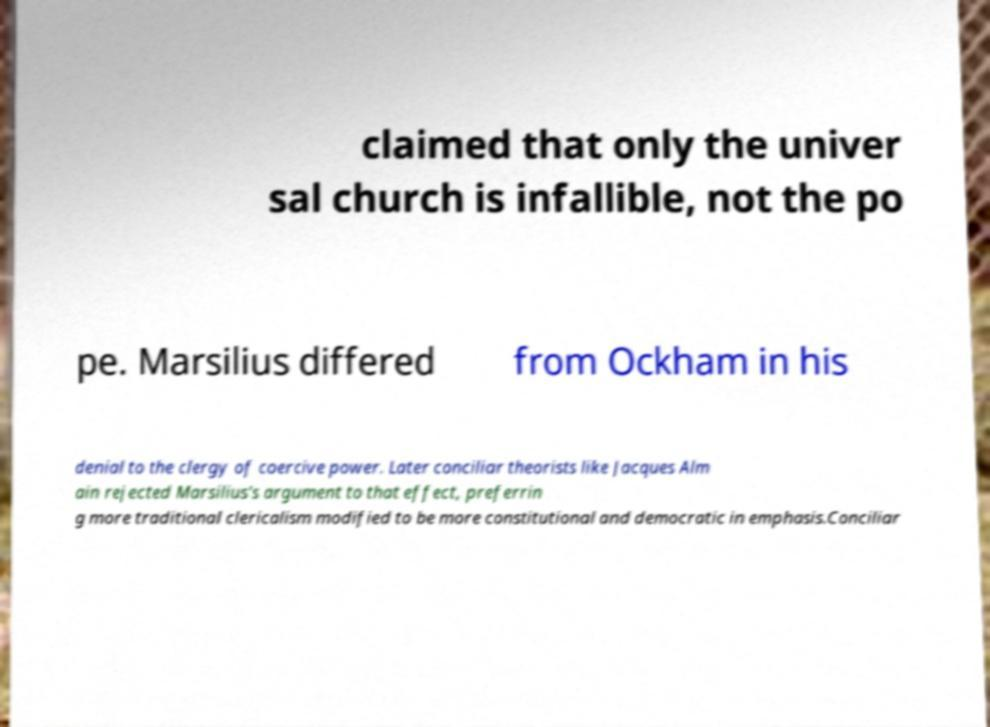There's text embedded in this image that I need extracted. Can you transcribe it verbatim? claimed that only the univer sal church is infallible, not the po pe. Marsilius differed from Ockham in his denial to the clergy of coercive power. Later conciliar theorists like Jacques Alm ain rejected Marsilius's argument to that effect, preferrin g more traditional clericalism modified to be more constitutional and democratic in emphasis.Conciliar 